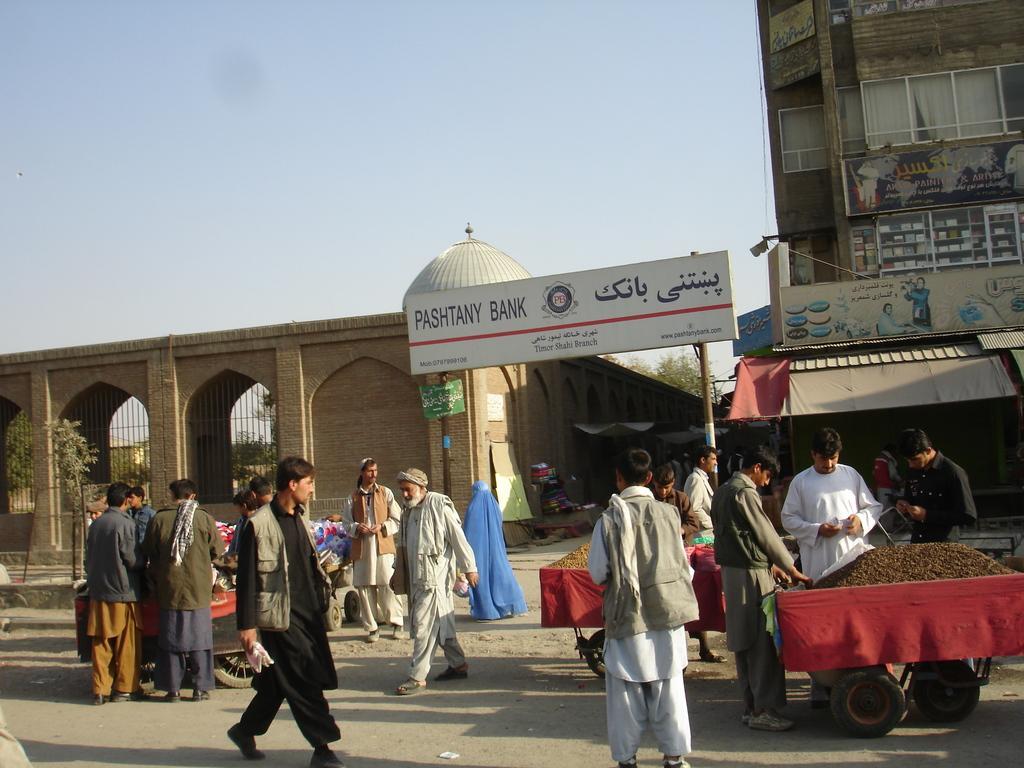Could you give a brief overview of what you see in this image? In this picture we can see few people are walking on the road, we can see some carts, behind we can see some buildings, boards. 